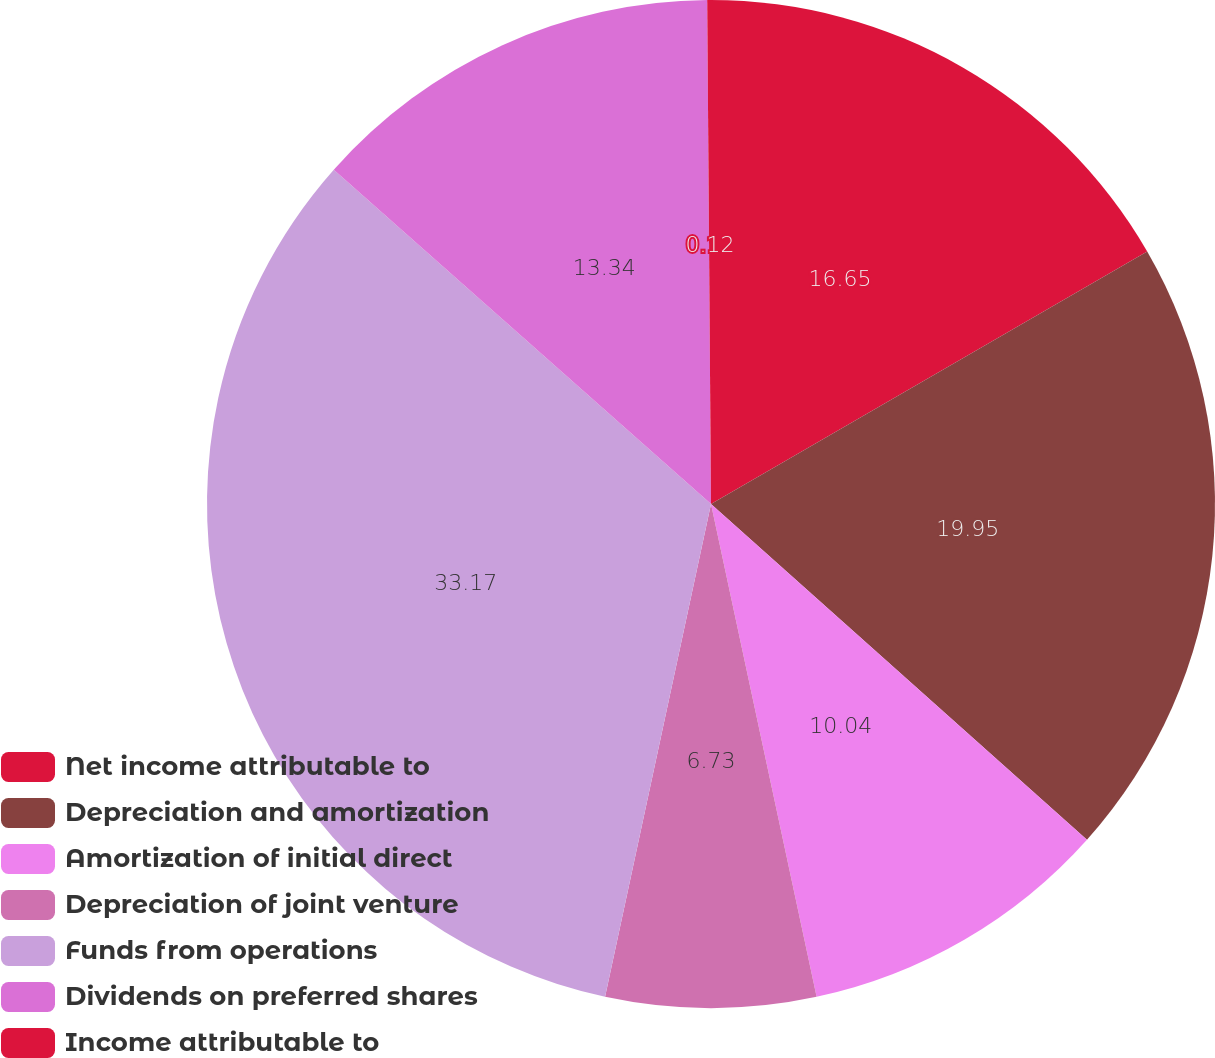<chart> <loc_0><loc_0><loc_500><loc_500><pie_chart><fcel>Net income attributable to<fcel>Depreciation and amortization<fcel>Amortization of initial direct<fcel>Depreciation of joint venture<fcel>Funds from operations<fcel>Dividends on preferred shares<fcel>Income attributable to<nl><fcel>16.65%<fcel>19.95%<fcel>10.04%<fcel>6.73%<fcel>33.17%<fcel>13.34%<fcel>0.12%<nl></chart> 